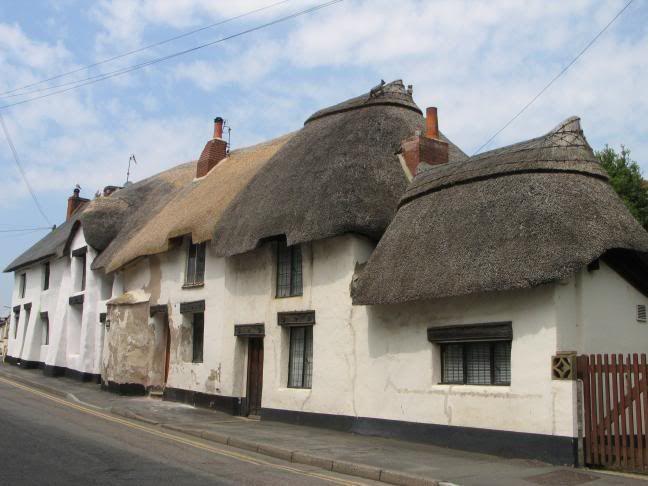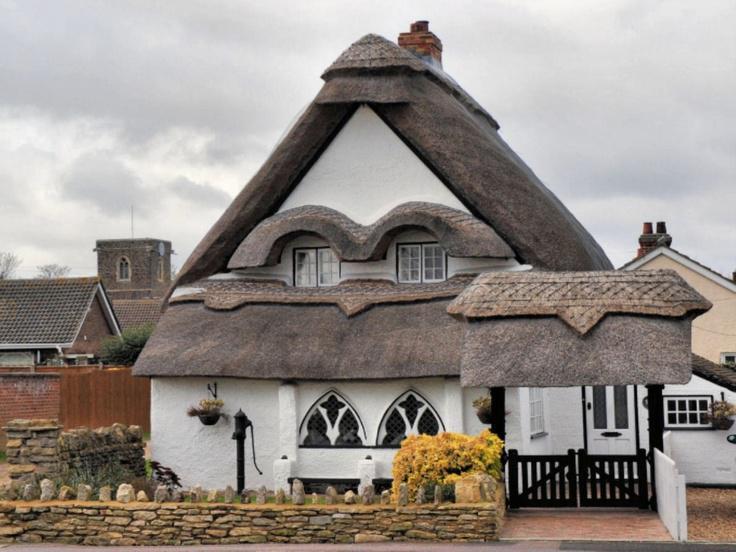The first image is the image on the left, the second image is the image on the right. For the images displayed, is the sentence "A road is seen to the left of the building in one image and not in the other." factually correct? Answer yes or no. Yes. The first image is the image on the left, the second image is the image on the right. For the images displayed, is the sentence "The right image shows the peaked front of a building with a thatched roof that curves around at least one dormer window extending out of the upper front of the house." factually correct? Answer yes or no. Yes. 